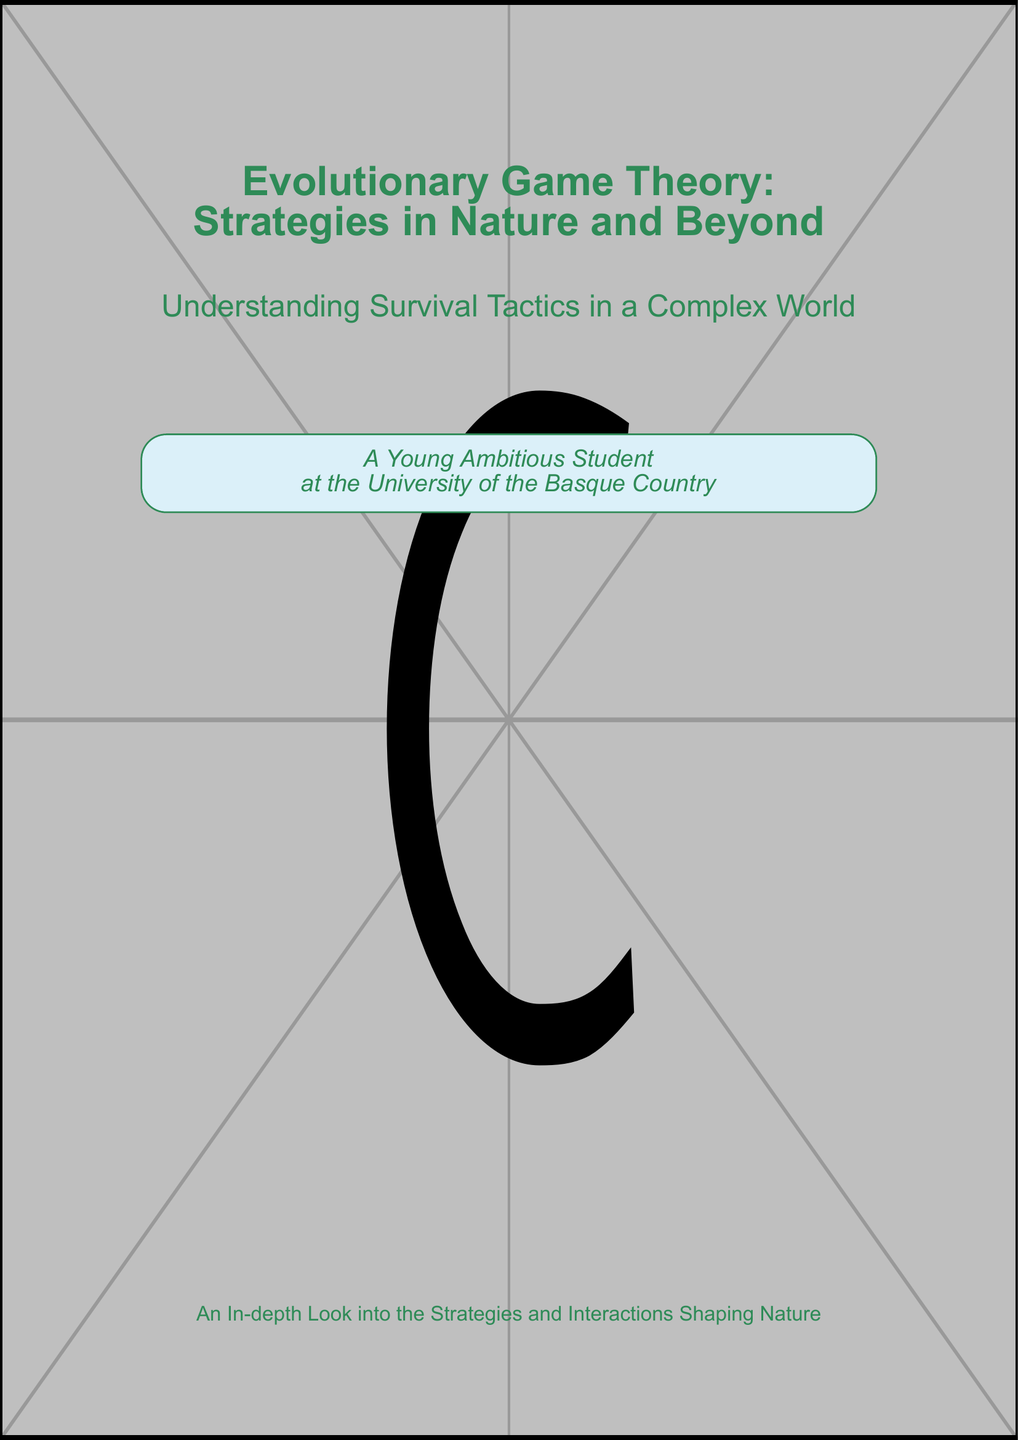What is the title of the book? The title is prominently displayed in large text on the cover of the document.
Answer: Evolutionary Game Theory: Strategies in Nature and Beyond What is the subtitle of the book? The subtitle offers a description of the book's focus and is located just below the title.
Answer: Understanding Survival Tactics in a Complex World What is depicted in the cover's background? The cover features a lively ecosystem scene, which is part of the design elements.
Answer: A lively ecosystem scene Who is the intended audience mentioned on the cover? The cover includes a reference to a person associated with the academic context, indicating the target audience.
Answer: A Young Ambitious Student What university is mentioned on the cover? The cover notes the educational institution that relates to the intended audience.
Answer: University of the Basque Country What color is the text on the cover? The text color is specified in the document, contributing to the visual design.
Answer: Dark green What color is used for the background? The background color is indicated as part of the document design attributes.
Answer: Light blue What is the purpose of the tcolorbox on the cover? The tcolorbox is used to highlight a specific piece of information about the audience.
Answer: To emphasize the intended audience How many main sections does the cover have in terms of titles? The cover clearly separates the main title and subtitle, indicating its structure.
Answer: Two main sections 